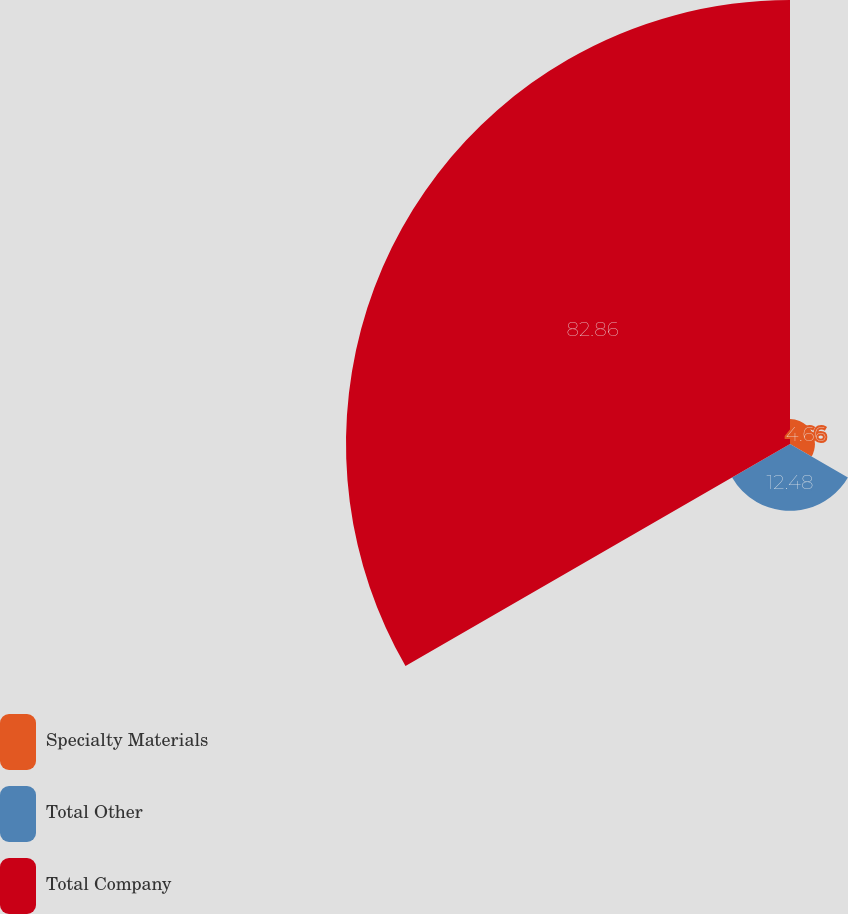<chart> <loc_0><loc_0><loc_500><loc_500><pie_chart><fcel>Specialty Materials<fcel>Total Other<fcel>Total Company<nl><fcel>4.66%<fcel>12.48%<fcel>82.86%<nl></chart> 